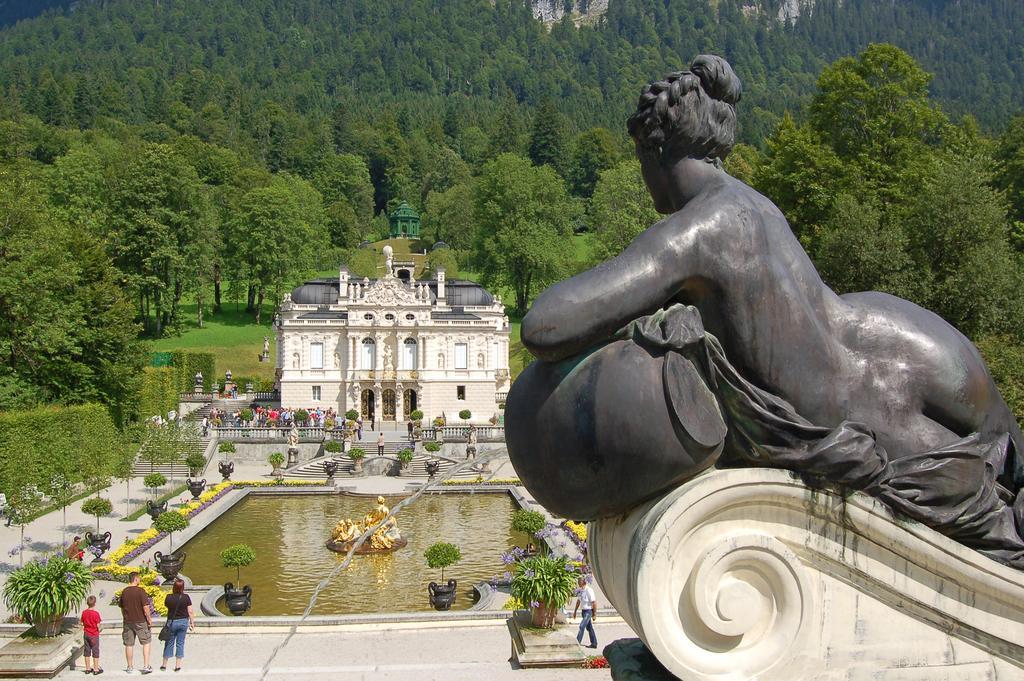How would you summarize this image in a sentence or two? There is a statue in the right corner and there are few people and a building in front of it and there are trees in the background. 